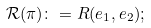<formula> <loc_0><loc_0><loc_500><loc_500>\mathcal { R } ( \pi ) \colon = R ( e _ { 1 } , e _ { 2 } ) ;</formula> 